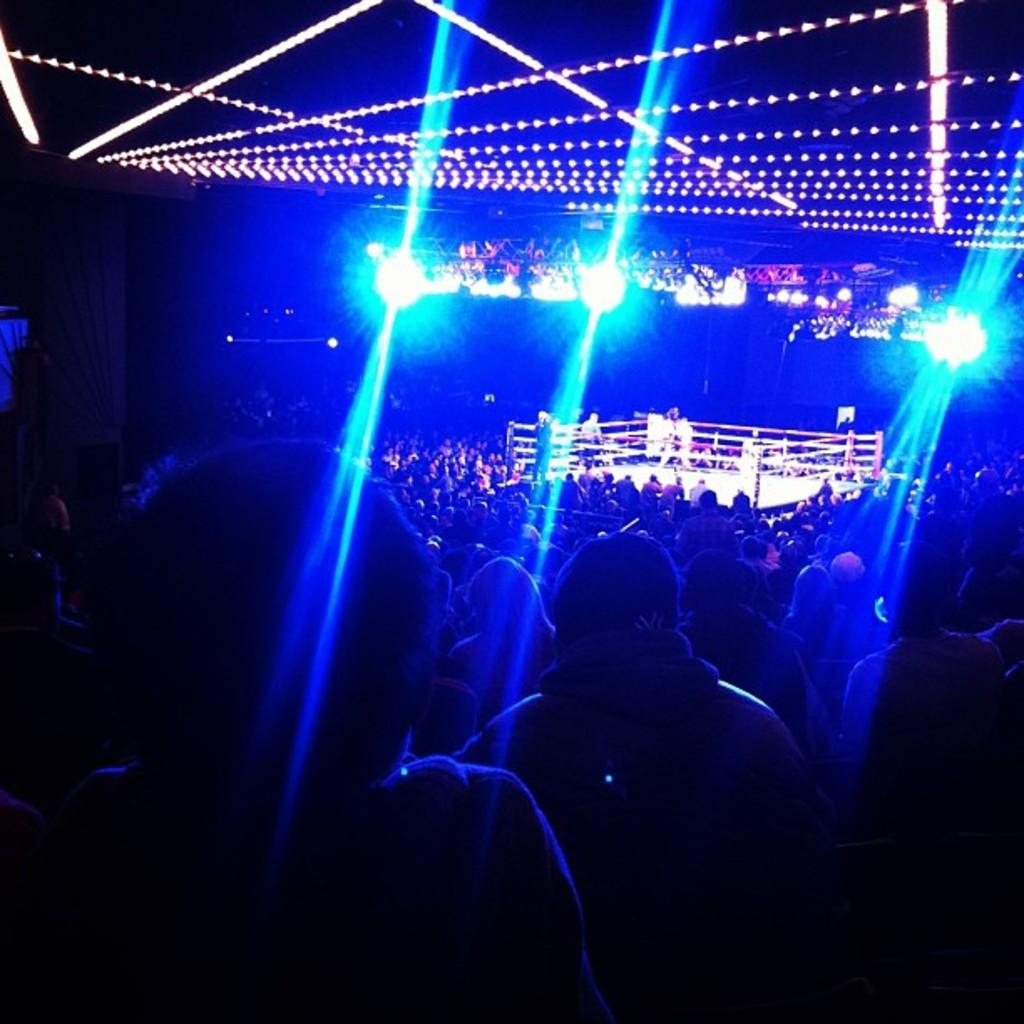How many people are present in the image? There are many people in the image. What can be observed about the lighting in the image? There are lights visible in the image. What is the main feature of the image? There is a battle ring in the image. How many people are inside the battle ring? There are three people in the battle ring. What type of account is being discussed by the people in the image? There is no mention of an account in the image; it primarily features a battle ring with people inside it. Can you see a toad in the image? There is no toad present in the image. 